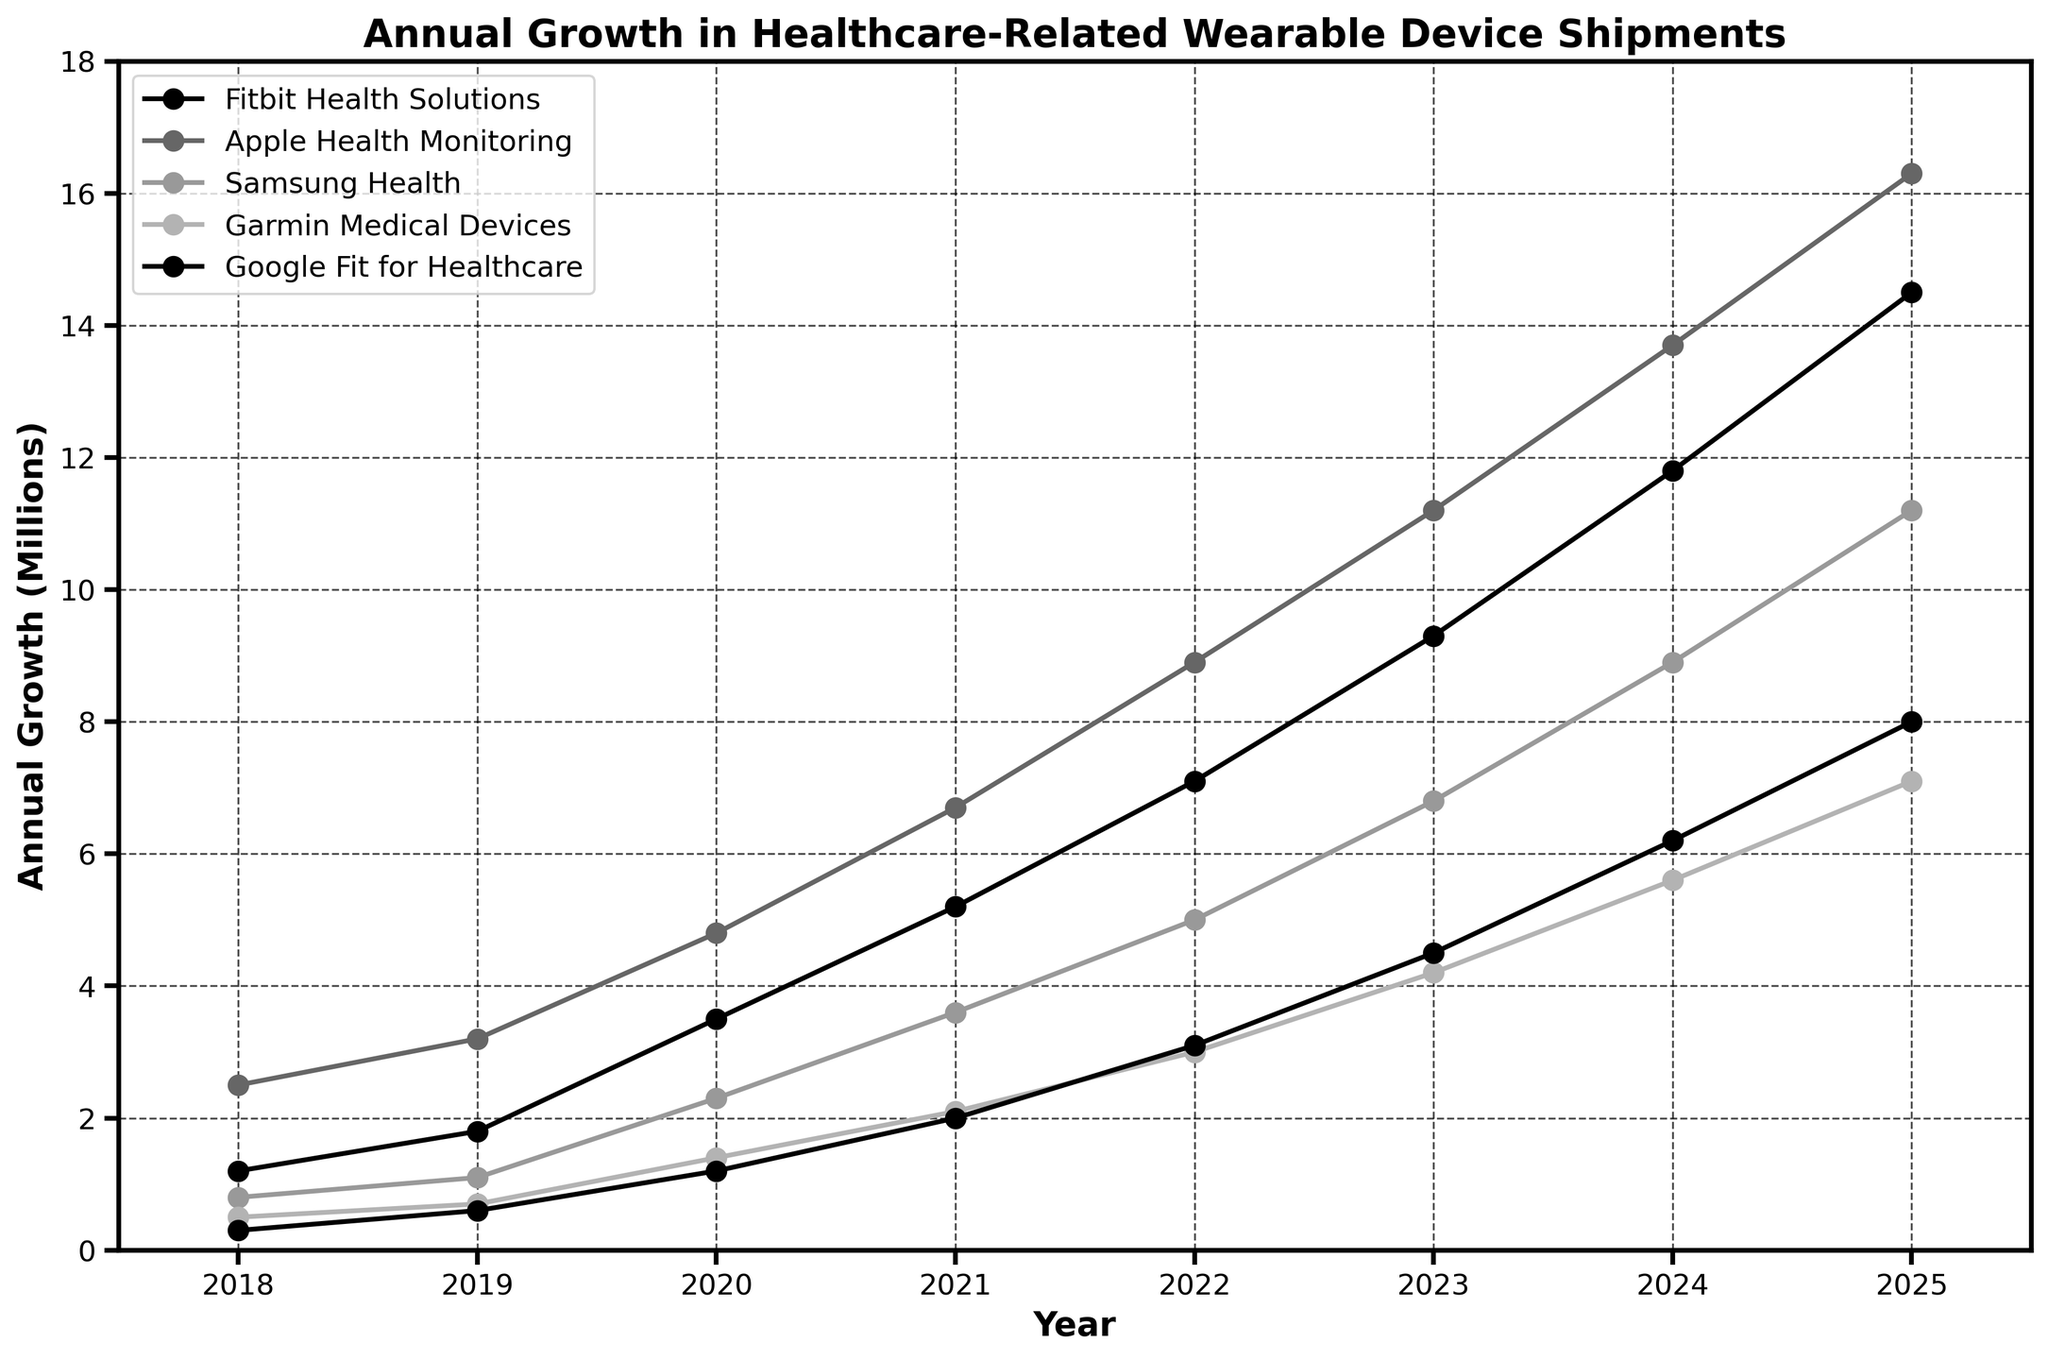What was the annual growth in Fitbit Health Solutions in 2021? Check the point in the Fitbit Health Solutions line at the year 2021, which is at the value of 5.2 million.
Answer: 5.2 How many years did it take for Google Fit for Healthcare to surpass 4 million in annual growth? Google Fit for Healthcare reached 4.5 million in 2023, so it took from 2018 to 2023.
Answer: 5 years Which company saw the largest increase in annual growth between 2019 and 2020? Calculate the difference for each company between 2019 and 2020. Fitbit Health Solutions increased by 1.7, Apple Health Monitoring by 1.6, Samsung Health by 1.2, Garmin Medical Devices by 0.7, and Google Fit for Healthcare by 0.6. Fitbit Health Solutions had the largest increase.
Answer: Fitbit Health Solutions What is the overall trend for Garmin Medical Devices from 2018 to 2025? Observe the Garmin Medical Devices trend from 2018 to 2025, which shows a steady increase from 0.5 to 7.1 million.
Answer: Steady increase In which year did Apple Health Monitoring reach approximately double the growth it had in 2018? Apple Health Monitoring had a growth of 2.5 million in 2018. Approximately double would be around 5 million. Apple Health Monitoring reaches 4.8 million in 2020.
Answer: 2020 By how much did Fitbit Health Solutions grow between 2018 and 2025? Fitbit Health Solutions grew from 1.2 million in 2018 to 14.5 million in 2025. The increase is 14.5 - 1.2 = 13.3 million.
Answer: 13.3 million Which company maintained the most consistent rate of growth throughout the years? By visually comparing the line slopes, Apple Health Monitoring and Fitbit Health Solutions appear to have fairly consistent steady growth, but Apple Health Monitoring looks slightly more linear.
Answer: Apple Health Monitoring Did any company experience a decline in any year? By visually inspecting the lines for each company, all lines show an upward trend throughout the years without any decline.
Answer: No 